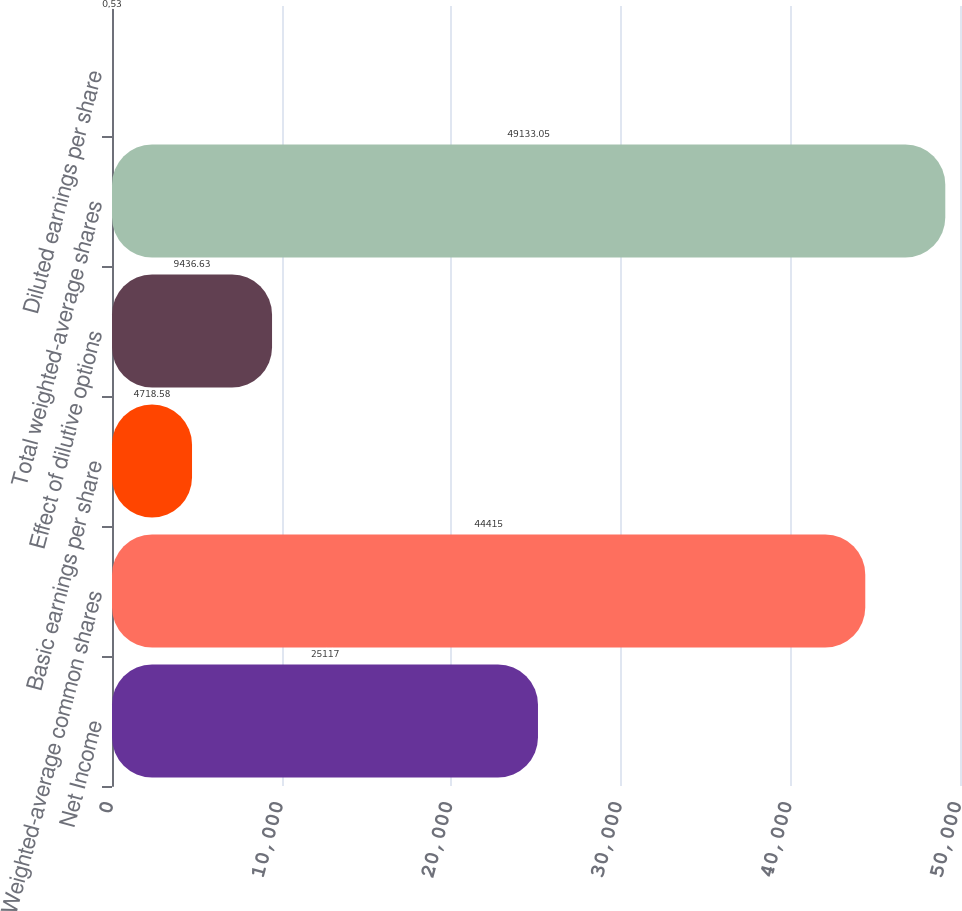Convert chart. <chart><loc_0><loc_0><loc_500><loc_500><bar_chart><fcel>Net Income<fcel>Weighted-average common shares<fcel>Basic earnings per share<fcel>Effect of dilutive options<fcel>Total weighted-average shares<fcel>Diluted earnings per share<nl><fcel>25117<fcel>44415<fcel>4718.58<fcel>9436.63<fcel>49133.1<fcel>0.53<nl></chart> 